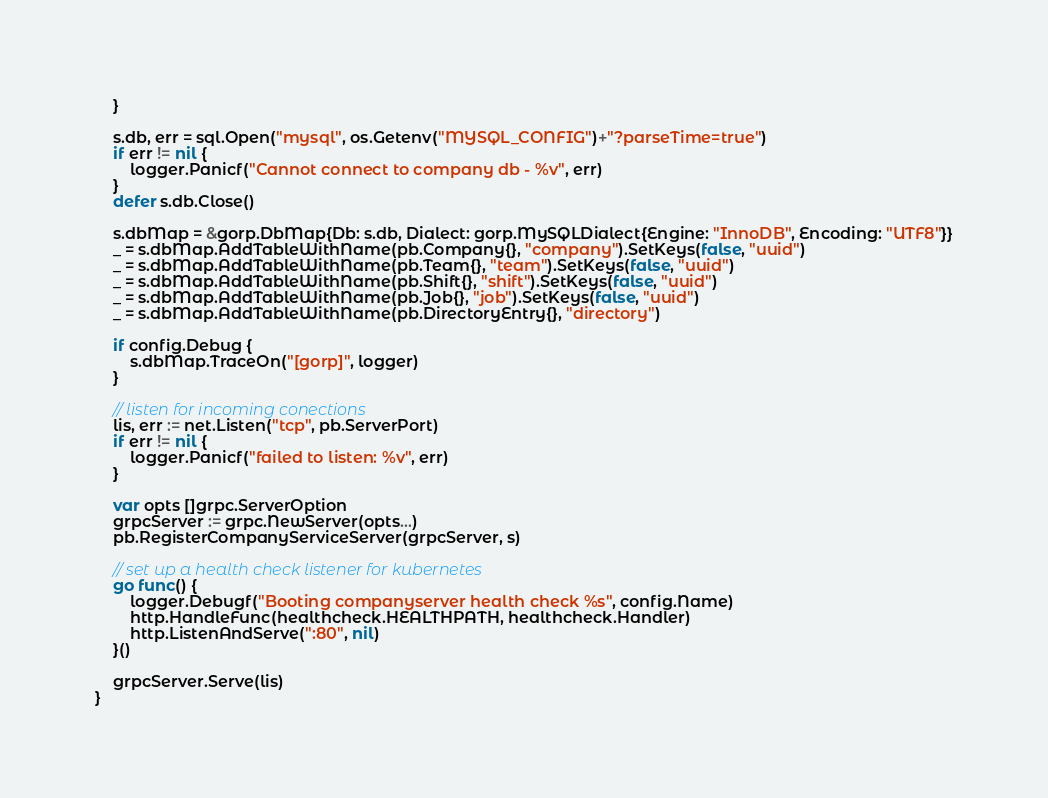<code> <loc_0><loc_0><loc_500><loc_500><_Go_>	}

	s.db, err = sql.Open("mysql", os.Getenv("MYSQL_CONFIG")+"?parseTime=true")
	if err != nil {
		logger.Panicf("Cannot connect to company db - %v", err)
	}
	defer s.db.Close()

	s.dbMap = &gorp.DbMap{Db: s.db, Dialect: gorp.MySQLDialect{Engine: "InnoDB", Encoding: "UTF8"}}
	_ = s.dbMap.AddTableWithName(pb.Company{}, "company").SetKeys(false, "uuid")
	_ = s.dbMap.AddTableWithName(pb.Team{}, "team").SetKeys(false, "uuid")
	_ = s.dbMap.AddTableWithName(pb.Shift{}, "shift").SetKeys(false, "uuid")
	_ = s.dbMap.AddTableWithName(pb.Job{}, "job").SetKeys(false, "uuid")
	_ = s.dbMap.AddTableWithName(pb.DirectoryEntry{}, "directory")

	if config.Debug {
		s.dbMap.TraceOn("[gorp]", logger)
	}

	// listen for incoming conections
	lis, err := net.Listen("tcp", pb.ServerPort)
	if err != nil {
		logger.Panicf("failed to listen: %v", err)
	}

	var opts []grpc.ServerOption
	grpcServer := grpc.NewServer(opts...)
	pb.RegisterCompanyServiceServer(grpcServer, s)

	// set up a health check listener for kubernetes
	go func() {
		logger.Debugf("Booting companyserver health check %s", config.Name)
		http.HandleFunc(healthcheck.HEALTHPATH, healthcheck.Handler)
		http.ListenAndServe(":80", nil)
	}()

	grpcServer.Serve(lis)
}
</code> 